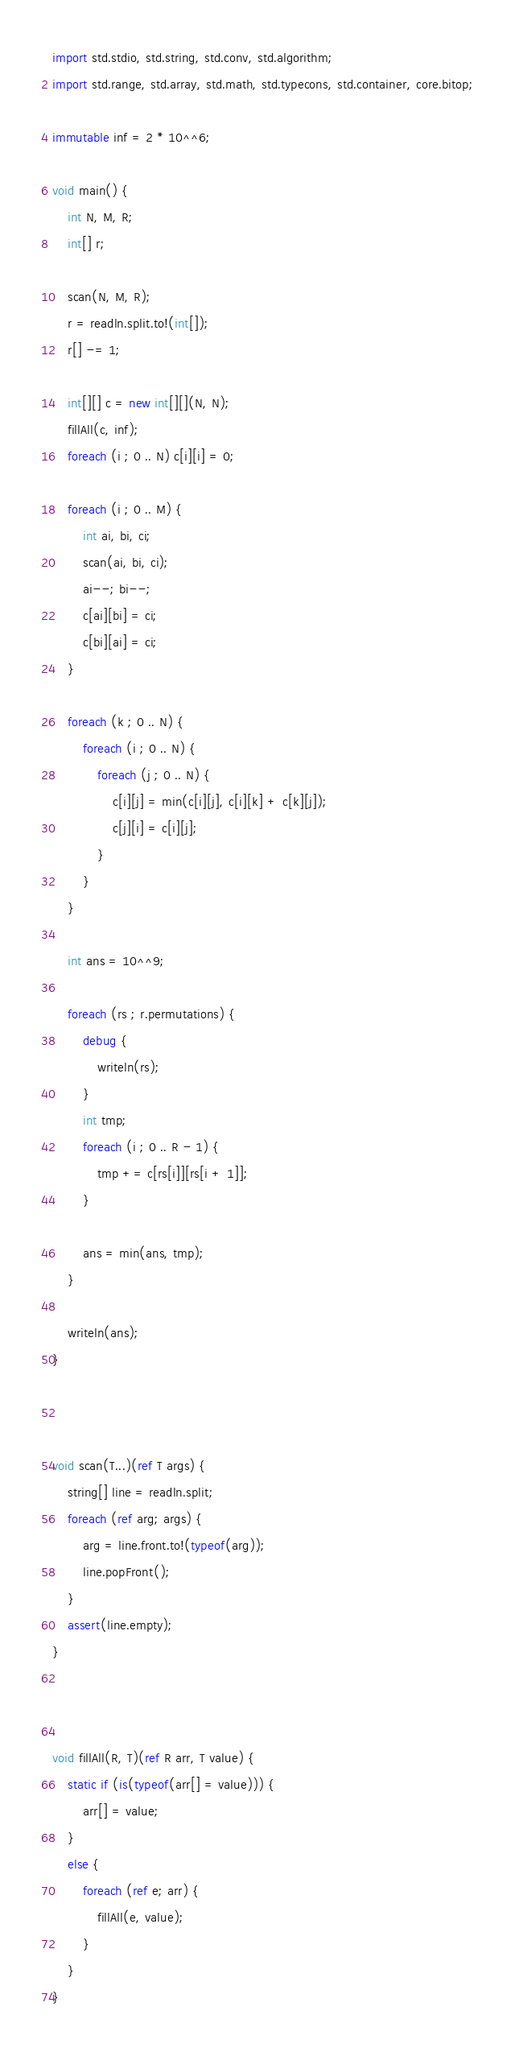Convert code to text. <code><loc_0><loc_0><loc_500><loc_500><_D_>import std.stdio, std.string, std.conv, std.algorithm;
import std.range, std.array, std.math, std.typecons, std.container, core.bitop;

immutable inf = 2 * 10^^6;

void main() {
    int N, M, R;
    int[] r;

    scan(N, M, R);
    r = readln.split.to!(int[]);
    r[] -= 1;

    int[][] c = new int[][](N, N);
    fillAll(c, inf);
    foreach (i ; 0 .. N) c[i][i] = 0;

    foreach (i ; 0 .. M) {
        int ai, bi, ci;
        scan(ai, bi, ci);
        ai--; bi--;
        c[ai][bi] = ci;
        c[bi][ai] = ci;
    }

    foreach (k ; 0 .. N) {
        foreach (i ; 0 .. N) {
            foreach (j ; 0 .. N) {
                c[i][j] = min(c[i][j], c[i][k] + c[k][j]);
                c[j][i] = c[i][j];
            }
        }
    }

    int ans = 10^^9;

    foreach (rs ; r.permutations) {
        debug {
            writeln(rs);
        }
        int tmp;
        foreach (i ; 0 .. R - 1) {
            tmp += c[rs[i]][rs[i + 1]];
        }

        ans = min(ans, tmp);
    }

    writeln(ans);
}



void scan(T...)(ref T args) {
    string[] line = readln.split;
    foreach (ref arg; args) {
        arg = line.front.to!(typeof(arg));
        line.popFront();
    }
    assert(line.empty);
}



void fillAll(R, T)(ref R arr, T value) {
    static if (is(typeof(arr[] = value))) {
        arr[] = value;
    }
    else {
        foreach (ref e; arr) {
            fillAll(e, value);
        }
    }
}</code> 